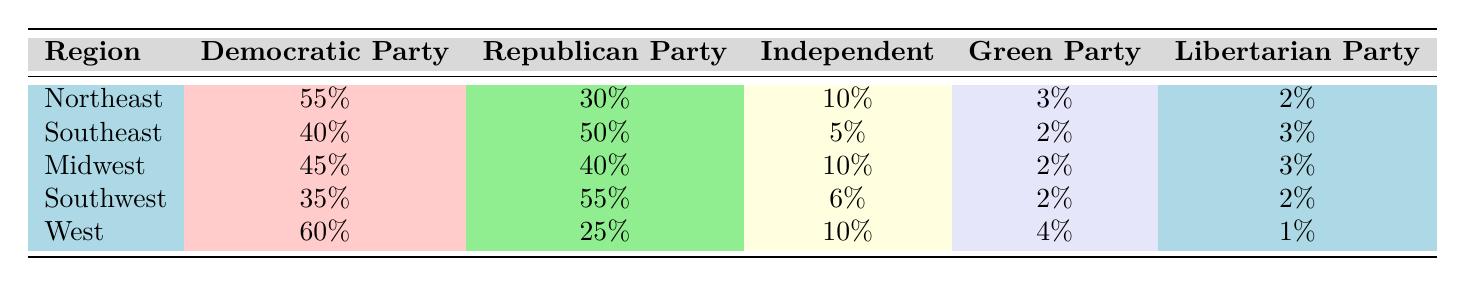What percentage of support did the Democratic Party receive in the Northeast region? The table shows the Democratic Party received 55% of support in the Northeast region.
Answer: 55% What is the Independent Party's support percentage in the Southeast region? Looking at the Southeast row in the table, the Independent Party received 5% of support.
Answer: 5% Which region had the highest support for the Republican Party? The Southwest region has the highest support for the Republican Party at 55%.
Answer: Southwest What is the total percentage of support for the Green Party across all regions? Adding the percentages from each region: 3% (Northeast) + 2% (Southeast) + 2% (Midwest) + 2% (Southwest) + 4% (West) gives us 13%.
Answer: 13% Which region has the least support for the Democratic Party? The Southwest region has the least support for the Democratic Party at 35%.
Answer: Southwest What is the difference in support for the Republican Party between the Southeast and Midwest regions? The support for the Republican Party is 50% in the Southeast and 40% in the Midwest. The difference is 50% - 40% = 10%.
Answer: 10% Is there a region with equal support for the Democratic and Republican parties? No, in all regions, one party has higher support than the other; no region has equal support.
Answer: No What percentage of support did the Libertarian Party receive in regions where the Democratic Party had less than 40% support? In the Southeast (40% Democratic) and Southwest (35% Democratic), the Libertarian Party received 3% and 2% respectively, totaling 5%.
Answer: 5% What is the average support for the Independent Party across all regions? The percentages for the Independent Party are 10% (Northeast), 5% (Southeast), 10% (Midwest), 6% (Southwest), and 10% (West). The total is 41%, and dividing by 5 gives an average of 8.2%.
Answer: 8.2% In which region does the Green Party have the highest support? The West region shows the highest support for the Green Party at 4%.
Answer: West How does the Republican Party's support in the Northeast compare to that in the West? The Republican Party has 30% support in the Northeast and 25% in the West, so it is higher in the Northeast by 5%.
Answer: Northeast by 5% Which political party has the highest overall support in the Midwest? The Democratic Party has the highest support in the Midwest at 45%.
Answer: Democratic Party 